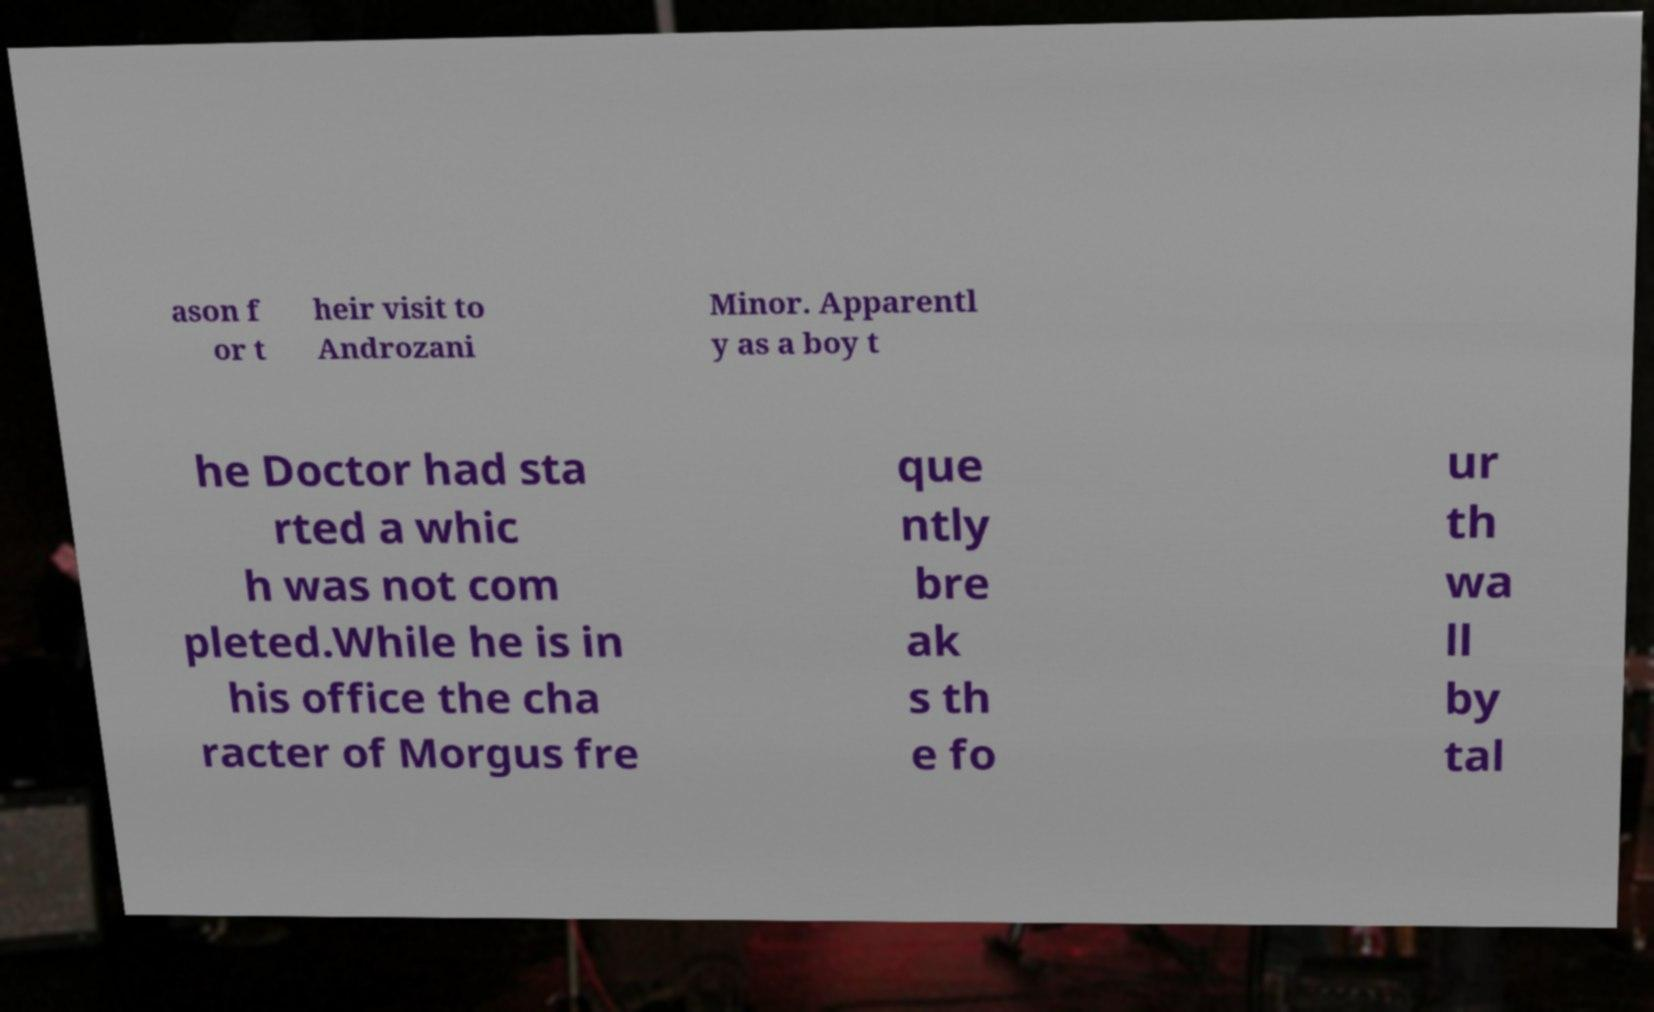I need the written content from this picture converted into text. Can you do that? ason f or t heir visit to Androzani Minor. Apparentl y as a boy t he Doctor had sta rted a whic h was not com pleted.While he is in his office the cha racter of Morgus fre que ntly bre ak s th e fo ur th wa ll by tal 